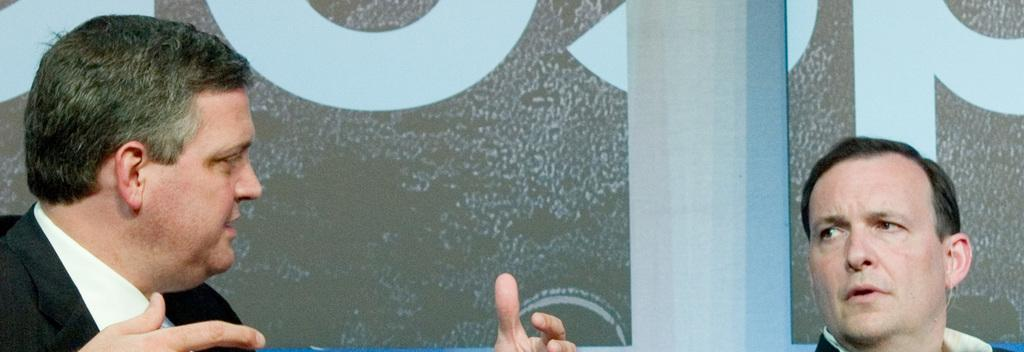How many people are in the image? There are two men in the image. What are the men wearing? The men are wearing black suits. What are the men doing in the image? The men are talking with each other. What can be seen in the background of the image? There is a wall in the background of the image. What type of songs can be heard in the image? There is no audio in the image, so it is not possible to determine what songs might be heard. 